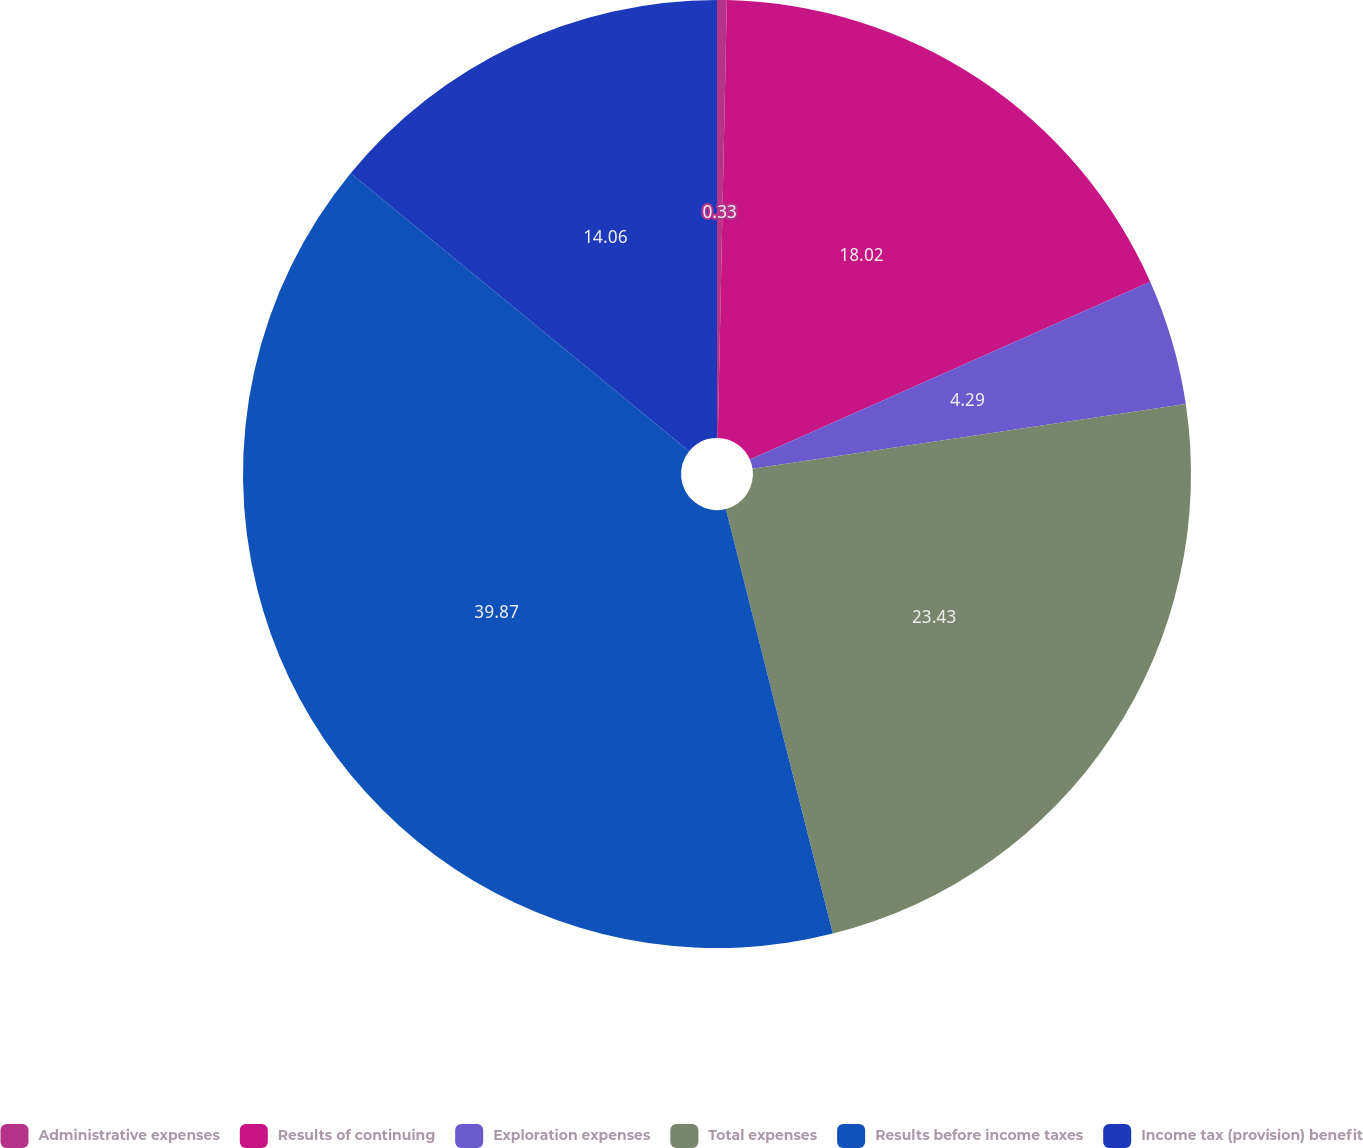Convert chart to OTSL. <chart><loc_0><loc_0><loc_500><loc_500><pie_chart><fcel>Administrative expenses<fcel>Results of continuing<fcel>Exploration expenses<fcel>Total expenses<fcel>Results before income taxes<fcel>Income tax (provision) benefit<nl><fcel>0.33%<fcel>18.02%<fcel>4.29%<fcel>23.43%<fcel>39.87%<fcel>14.06%<nl></chart> 